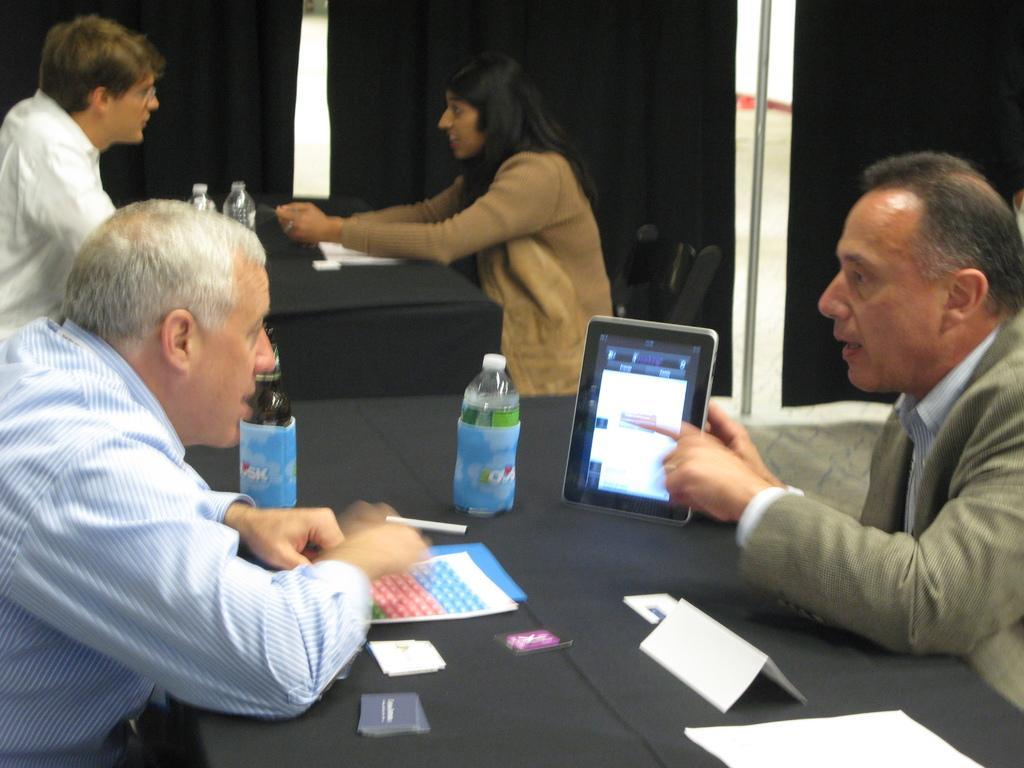Could you give a brief overview of what you see in this image? The image consist of four people. The image is clicked inside the room. To the left the man is wearing blue shirt. To the right, the man is wearing green suit. In the middle, there is a table covered with black cloth. On which bottle, books, cards , nameplate are kept. In the background, there are curtains stand. 